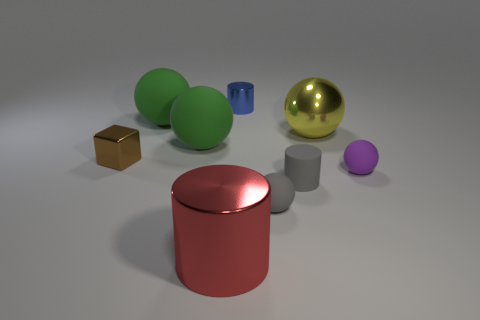There is a metal cylinder in front of the cylinder that is on the right side of the blue cylinder that is on the right side of the big red cylinder; what color is it?
Your response must be concise. Red. Are there any tiny green metallic things that have the same shape as the red object?
Provide a succinct answer. No. There is a cylinder that is the same size as the yellow metal sphere; what is its color?
Provide a succinct answer. Red. What material is the cylinder that is behind the yellow metallic thing?
Keep it short and to the point. Metal. Do the tiny brown metallic object left of the small purple object and the large shiny thing that is right of the small blue shiny cylinder have the same shape?
Ensure brevity in your answer.  No. Are there the same number of tiny gray objects in front of the large cylinder and large brown cubes?
Give a very brief answer. Yes. What number of other tiny purple things are made of the same material as the purple object?
Keep it short and to the point. 0. There is another tiny ball that is made of the same material as the purple ball; what color is it?
Your answer should be very brief. Gray. There is a rubber cylinder; is its size the same as the green ball behind the big yellow sphere?
Ensure brevity in your answer.  No. The tiny purple matte thing is what shape?
Your answer should be very brief. Sphere. 